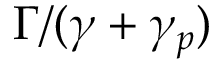Convert formula to latex. <formula><loc_0><loc_0><loc_500><loc_500>\Gamma / ( \gamma + \gamma _ { p } )</formula> 